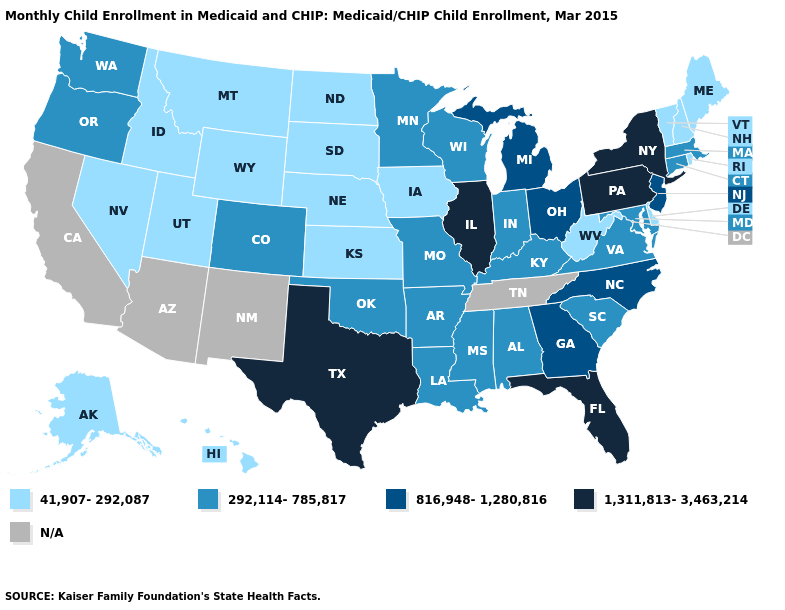Among the states that border South Dakota , which have the highest value?
Give a very brief answer. Minnesota. Name the states that have a value in the range 41,907-292,087?
Keep it brief. Alaska, Delaware, Hawaii, Idaho, Iowa, Kansas, Maine, Montana, Nebraska, Nevada, New Hampshire, North Dakota, Rhode Island, South Dakota, Utah, Vermont, West Virginia, Wyoming. Among the states that border Florida , which have the lowest value?
Quick response, please. Alabama. Does Indiana have the highest value in the MidWest?
Short answer required. No. Name the states that have a value in the range N/A?
Be succinct. Arizona, California, New Mexico, Tennessee. Is the legend a continuous bar?
Concise answer only. No. Which states have the highest value in the USA?
Be succinct. Florida, Illinois, New York, Pennsylvania, Texas. Which states hav the highest value in the Northeast?
Answer briefly. New York, Pennsylvania. Name the states that have a value in the range N/A?
Keep it brief. Arizona, California, New Mexico, Tennessee. Name the states that have a value in the range 1,311,813-3,463,214?
Answer briefly. Florida, Illinois, New York, Pennsylvania, Texas. Is the legend a continuous bar?
Concise answer only. No. Name the states that have a value in the range 1,311,813-3,463,214?
Keep it brief. Florida, Illinois, New York, Pennsylvania, Texas. Does Idaho have the lowest value in the West?
Be succinct. Yes. What is the value of Washington?
Give a very brief answer. 292,114-785,817. 